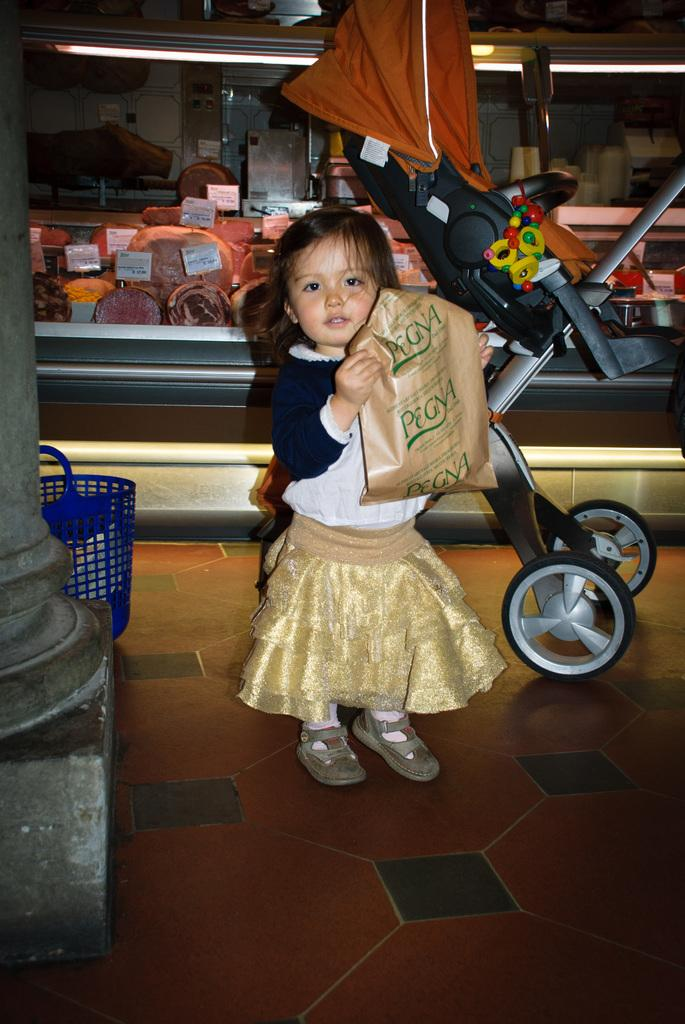What is the girl in the image doing? The girl is standing in the image and holding a cover. What can be seen near the girl in the image? There is a pole in the image. What is located on the left side of the image? There is a blue basket on the left side of the image. What type of illumination is present in the image? There are lights in the image. What other objects can be seen in the background of the image? There are other objects visible at the back of the image. How does the girl compare her pump to the picture in the image? There is no pump or picture present in the image, so it is not possible to answer that question. 